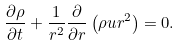<formula> <loc_0><loc_0><loc_500><loc_500>\frac { { \partial } { \rho } } { { \partial } t } + \frac { 1 } { r ^ { 2 } } \frac { \partial } { { \partial } r } \left ( { \rho } u r ^ { 2 } \right ) = 0 .</formula> 